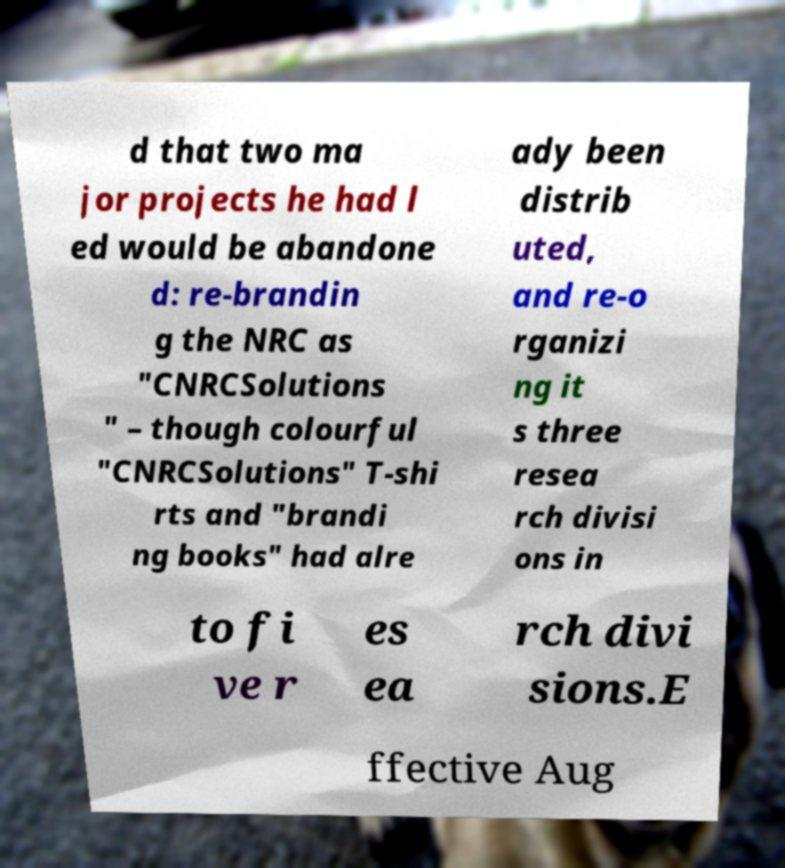There's text embedded in this image that I need extracted. Can you transcribe it verbatim? d that two ma jor projects he had l ed would be abandone d: re-brandin g the NRC as "CNRCSolutions " – though colourful "CNRCSolutions" T-shi rts and "brandi ng books" had alre ady been distrib uted, and re-o rganizi ng it s three resea rch divisi ons in to fi ve r es ea rch divi sions.E ffective Aug 